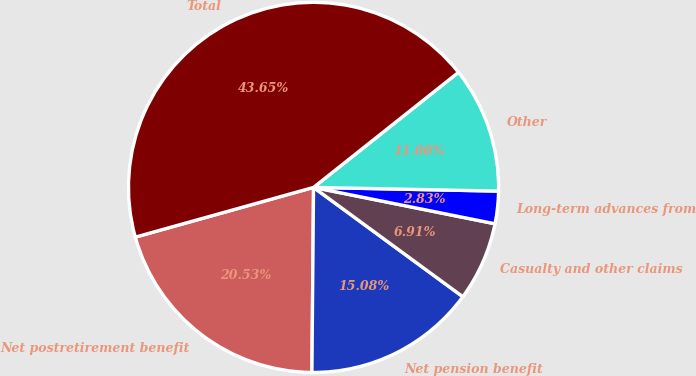<chart> <loc_0><loc_0><loc_500><loc_500><pie_chart><fcel>Net postretirement benefit<fcel>Net pension benefit<fcel>Casualty and other claims<fcel>Long-term advances from<fcel>Other<fcel>Total<nl><fcel>20.53%<fcel>15.08%<fcel>6.91%<fcel>2.83%<fcel>11.0%<fcel>43.65%<nl></chart> 